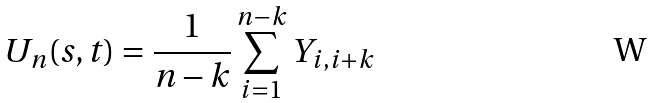<formula> <loc_0><loc_0><loc_500><loc_500>U _ { n } ( s , t ) = \frac { 1 } { n - k } \sum _ { i = 1 } ^ { n - k } Y _ { i , i + k }</formula> 